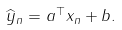Convert formula to latex. <formula><loc_0><loc_0><loc_500><loc_500>\widehat { y } _ { n } = { a } ^ { \top } { x } _ { n } + b .</formula> 